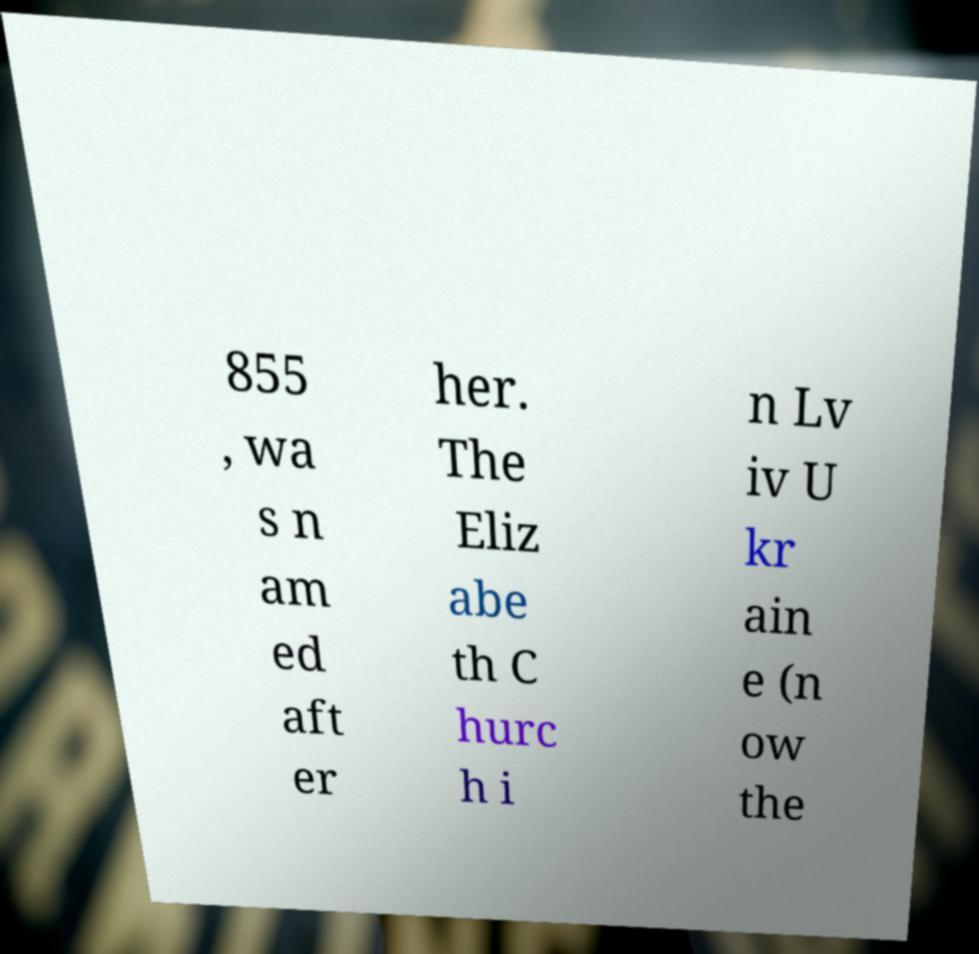For documentation purposes, I need the text within this image transcribed. Could you provide that? 855 , wa s n am ed aft er her. The Eliz abe th C hurc h i n Lv iv U kr ain e (n ow the 